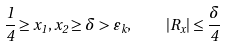<formula> <loc_0><loc_0><loc_500><loc_500>\frac { 1 } { 4 } \geq x _ { 1 } , x _ { 2 } \geq \delta > \varepsilon _ { k } , \quad | R _ { x } | \leq \frac { \delta } { 4 }</formula> 